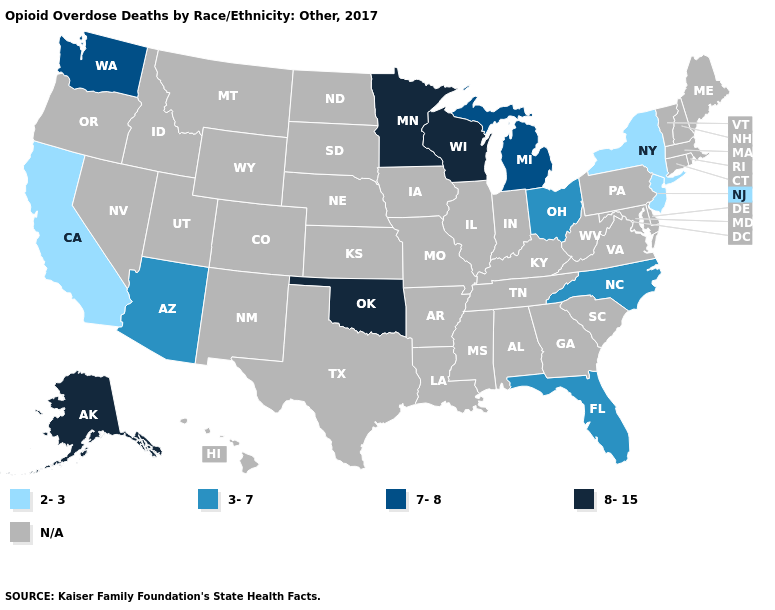Name the states that have a value in the range 2-3?
Concise answer only. California, New Jersey, New York. What is the lowest value in the South?
Be succinct. 3-7. How many symbols are there in the legend?
Short answer required. 5. What is the value of Alabama?
Write a very short answer. N/A. Name the states that have a value in the range 7-8?
Concise answer only. Michigan, Washington. Which states have the lowest value in the West?
Short answer required. California. What is the value of Alaska?
Keep it brief. 8-15. Does Wisconsin have the lowest value in the MidWest?
Answer briefly. No. Among the states that border California , which have the highest value?
Quick response, please. Arizona. Name the states that have a value in the range 8-15?
Give a very brief answer. Alaska, Minnesota, Oklahoma, Wisconsin. Does the map have missing data?
Short answer required. Yes. Name the states that have a value in the range N/A?
Give a very brief answer. Alabama, Arkansas, Colorado, Connecticut, Delaware, Georgia, Hawaii, Idaho, Illinois, Indiana, Iowa, Kansas, Kentucky, Louisiana, Maine, Maryland, Massachusetts, Mississippi, Missouri, Montana, Nebraska, Nevada, New Hampshire, New Mexico, North Dakota, Oregon, Pennsylvania, Rhode Island, South Carolina, South Dakota, Tennessee, Texas, Utah, Vermont, Virginia, West Virginia, Wyoming. 